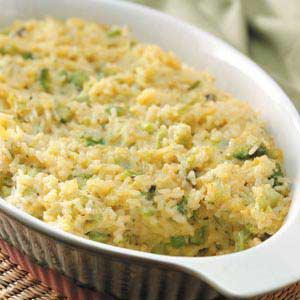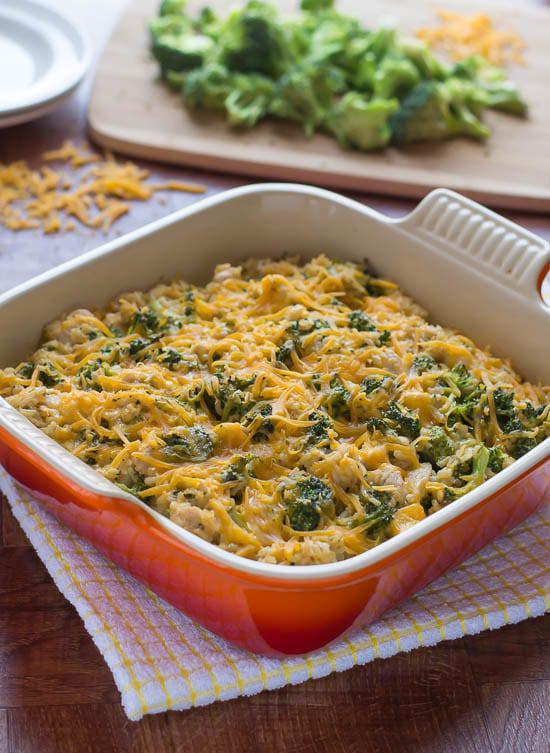The first image is the image on the left, the second image is the image on the right. Given the left and right images, does the statement "In one of the images there is a plate of broccoli casserole with a fork." hold true? Answer yes or no. No. 